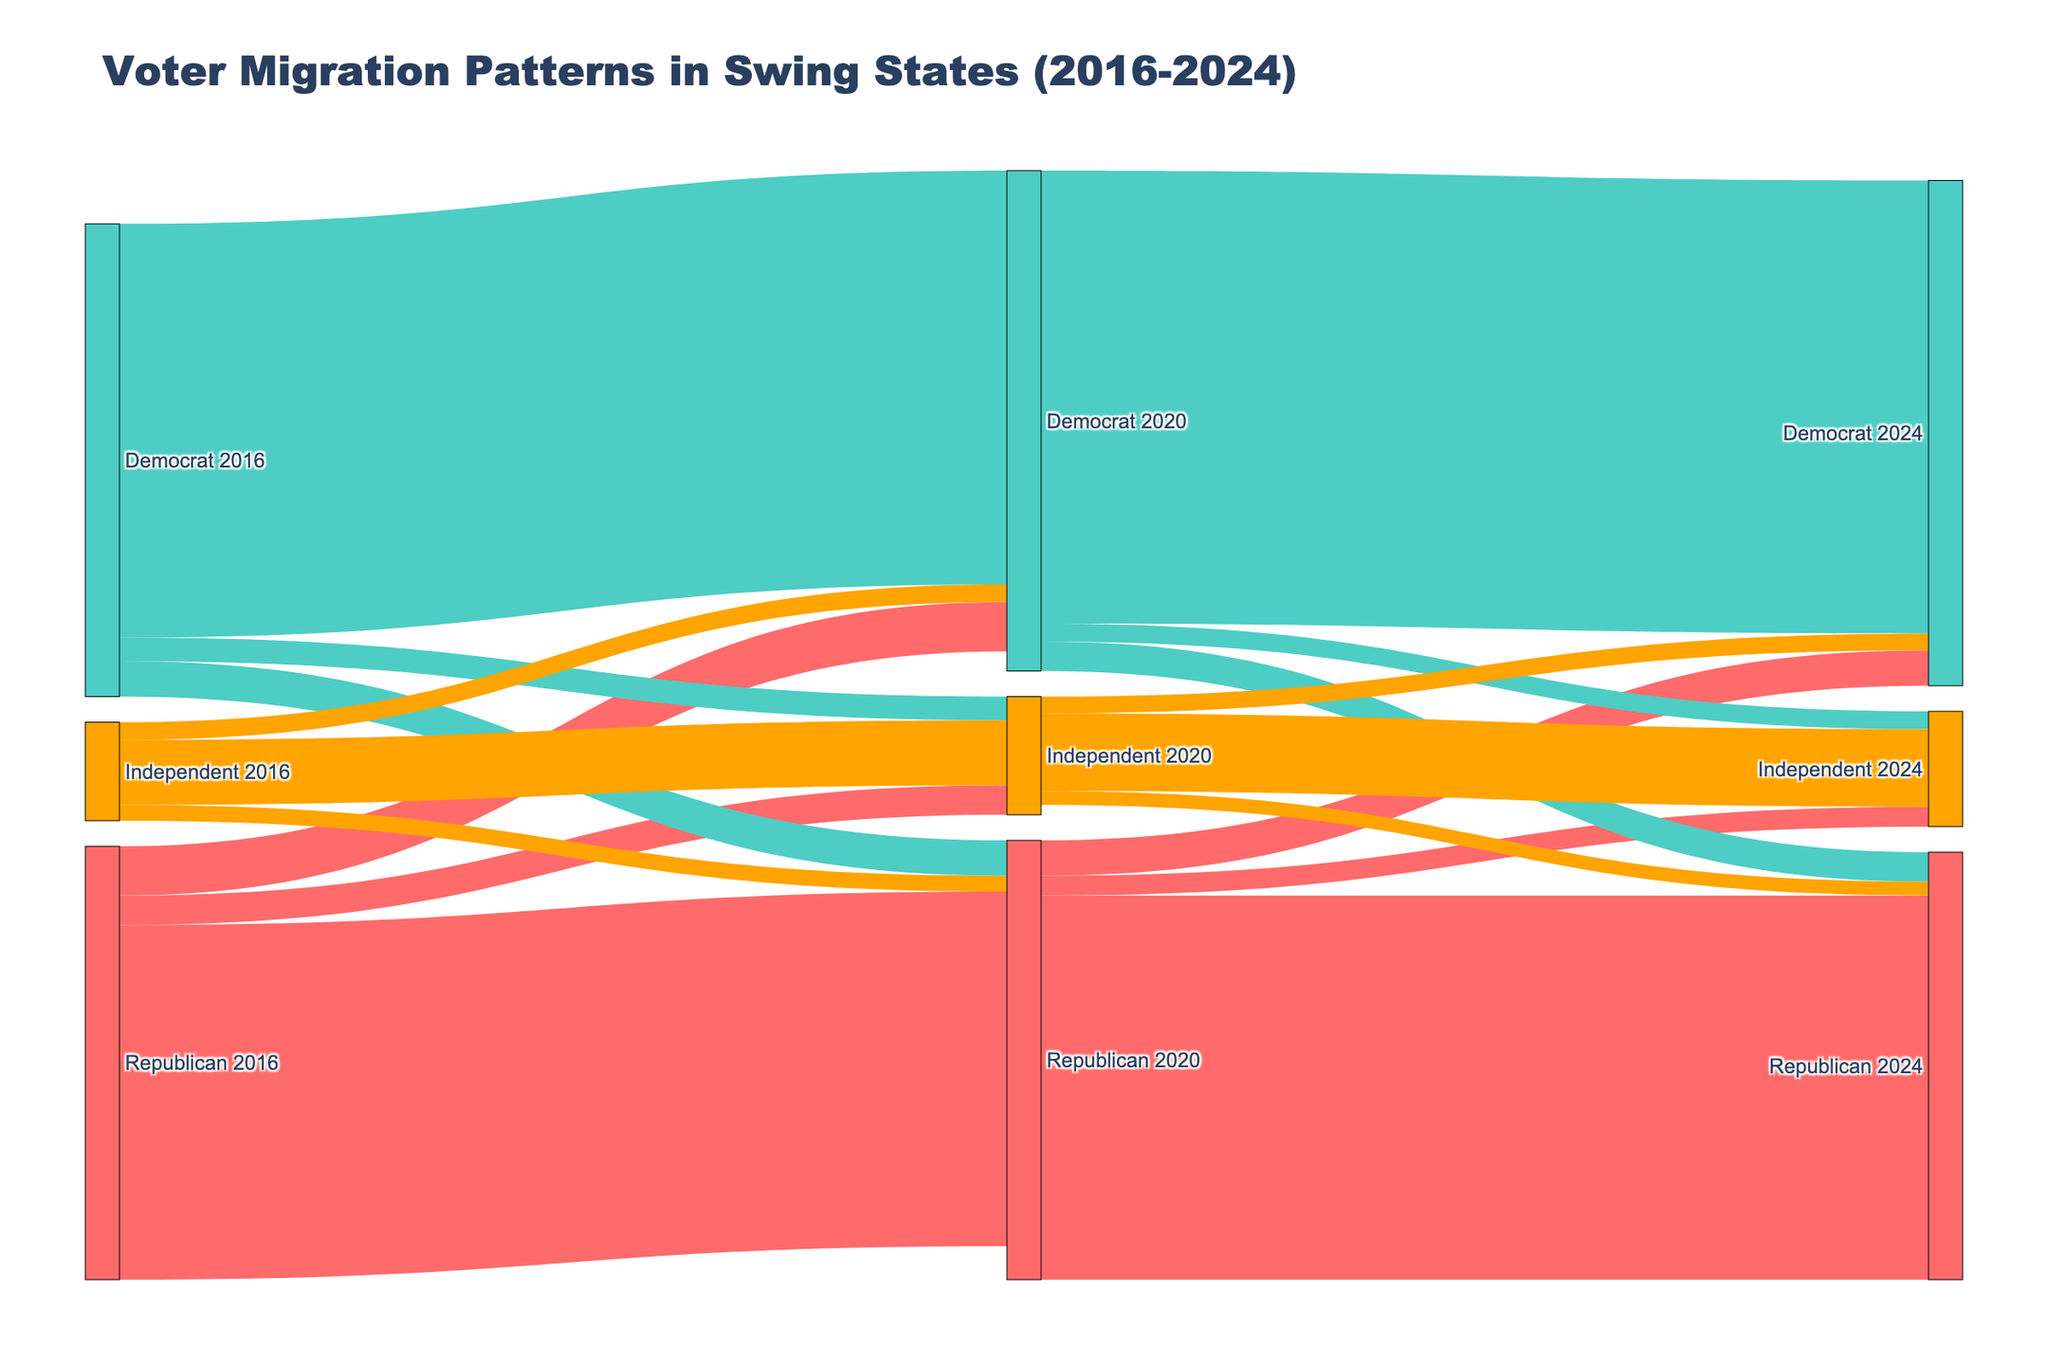what is the title of the Sankey diagram? The title of the Sankey diagram is located at the top center of the figure and provides a brief description of the data presented in the diagram.
Answer: Voter Migration Patterns in Swing States (2016-2024) How many total voters transitioned from the Republican party to the Democrat party between 2016 and 2020? By examining the flow lines, the number of voters transitioning from "Republican 2016" to "Democrat 2020" can be identified in the figure.
Answer: 250,000 How many voters were independent in both 2016 and 2020? One should observe the flow between the "Independent 2016" and "Independent 2020" nodes to get the number of voters who remained independent.
Answer: 330,000 What is the combined total of voters who switched from Democrat to Republican between 2016-2020 and 2020-2024? By adding the votes from "Democrat 2016" to "Republican 2020" and "Democrat 2020" to "Republican 2024," one can compute the combined total.
Answer: 330,000 How many more voters remained Republican from 2020 to 2024 compared to those who remained Democrat in the same period? Identify the numbers of voters who remained Republican and Democrat in the 2020 to 2024 period and find the difference. Republicans: 1,950,000; Democrats: 2,300,000.
Answer: 350,000 fewer Which group had the largest number of retained voters between 2020 and 2024? By looking at the node connections between 2020 and 2024 for each party, identify the group with the highest retained number of voters.
Answer: Democrats How many voters switched from being Independent in 2020 to either the Republican or Democrat parties in 2024? Sum the voters who switched from "Independent 2020" to "Republican 2024" and "Independent 2020" to "Democrat 2024."
Answer: 155,000 How many total voters switched away from the Democrat party in the 2020-2024 period? Adding the flows from "Democrat 2020" to both "Republican 2024" and "Independent 2024" gives the total voters who left the Democrat party.
Answer: 240,000 How does the number of voters who transitioned from being Republican to Independent between 2016 and 2020 compare to those who transitioned the same way between 2020 and 2024? The numbers from "Republican 2016" to "Independent 2020" and "Republican 2020" to "Independent 2024" should be compared directly.
Answer: 50,000 fewer What is the most significant voter migration pattern observed from the Republican party between 2016 and 2024? Identify the largest voter migration flow starting from "Republican 2016" over the periods until 2024. This involves checking both direct and indirect transitions over the periods.
Answer: Republican to Republican 